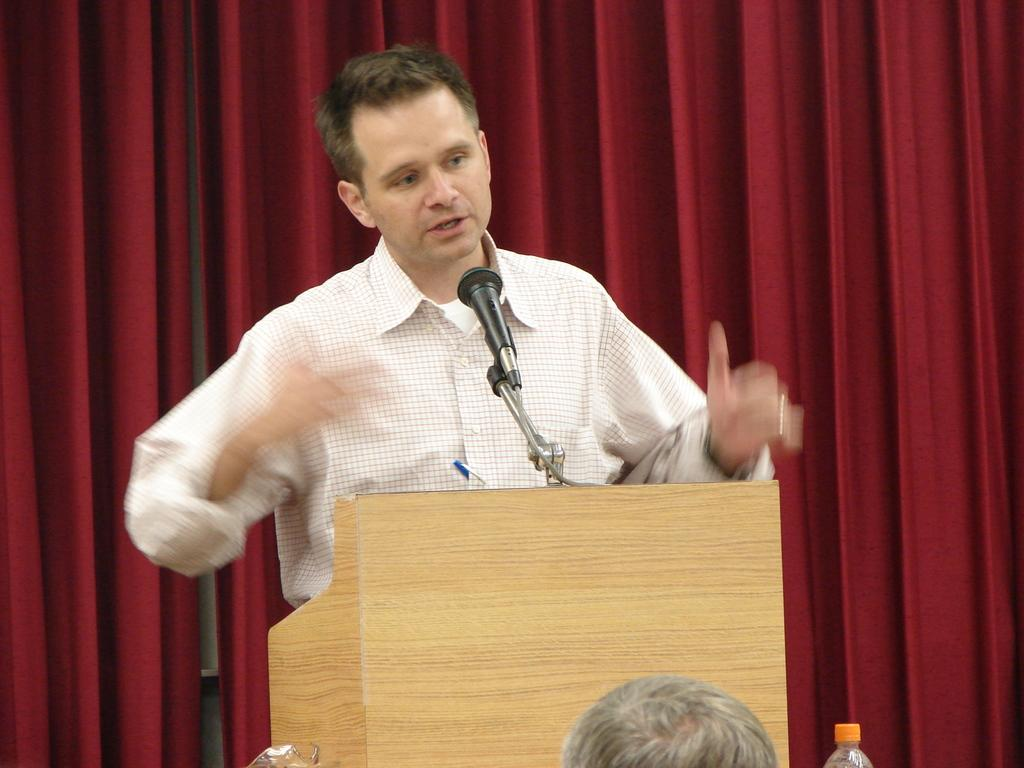Who is the main subject in the image? There is a man in the image. What is the man doing in the image? The man is standing at a speech desk and giving a speech. What can be seen in the background of the image? There is a red curtain in the background of the image. What type of friction is present between the man's shoes and the speech desk? There is no information about the friction between the man's shoes and the speech desk in the image. --- Facts: 1. There is a car in the image. 2. The car is parked on the street. 3. The car is red. 4. There are trees on the side of the street. 5. The sky is visible in the image. Absurd Topics: dance, rainbow, melody Conversation: What is the main subject in the image? There is a car in the image. Where is the car located in the image? The car is parked on the street. What color is the car? The car is red. What can be seen on the side of the street in the image? There are trees on the side of the street. What is visible in the background of the image? The sky is visible in the image. Reasoning: Let's think step by step in order to produce the conversation. We start by identifying the main subject in the image, which is the car. Then, we describe the car's location, color, and the surrounding environment, including the trees and the sky. Each question is designed to elicit a specific detail about the image that is known from the provided facts. Absurd Question/Answer: Can you hear the melody being played by the car in the image? There is no information about a melody being played by the car in the image. 